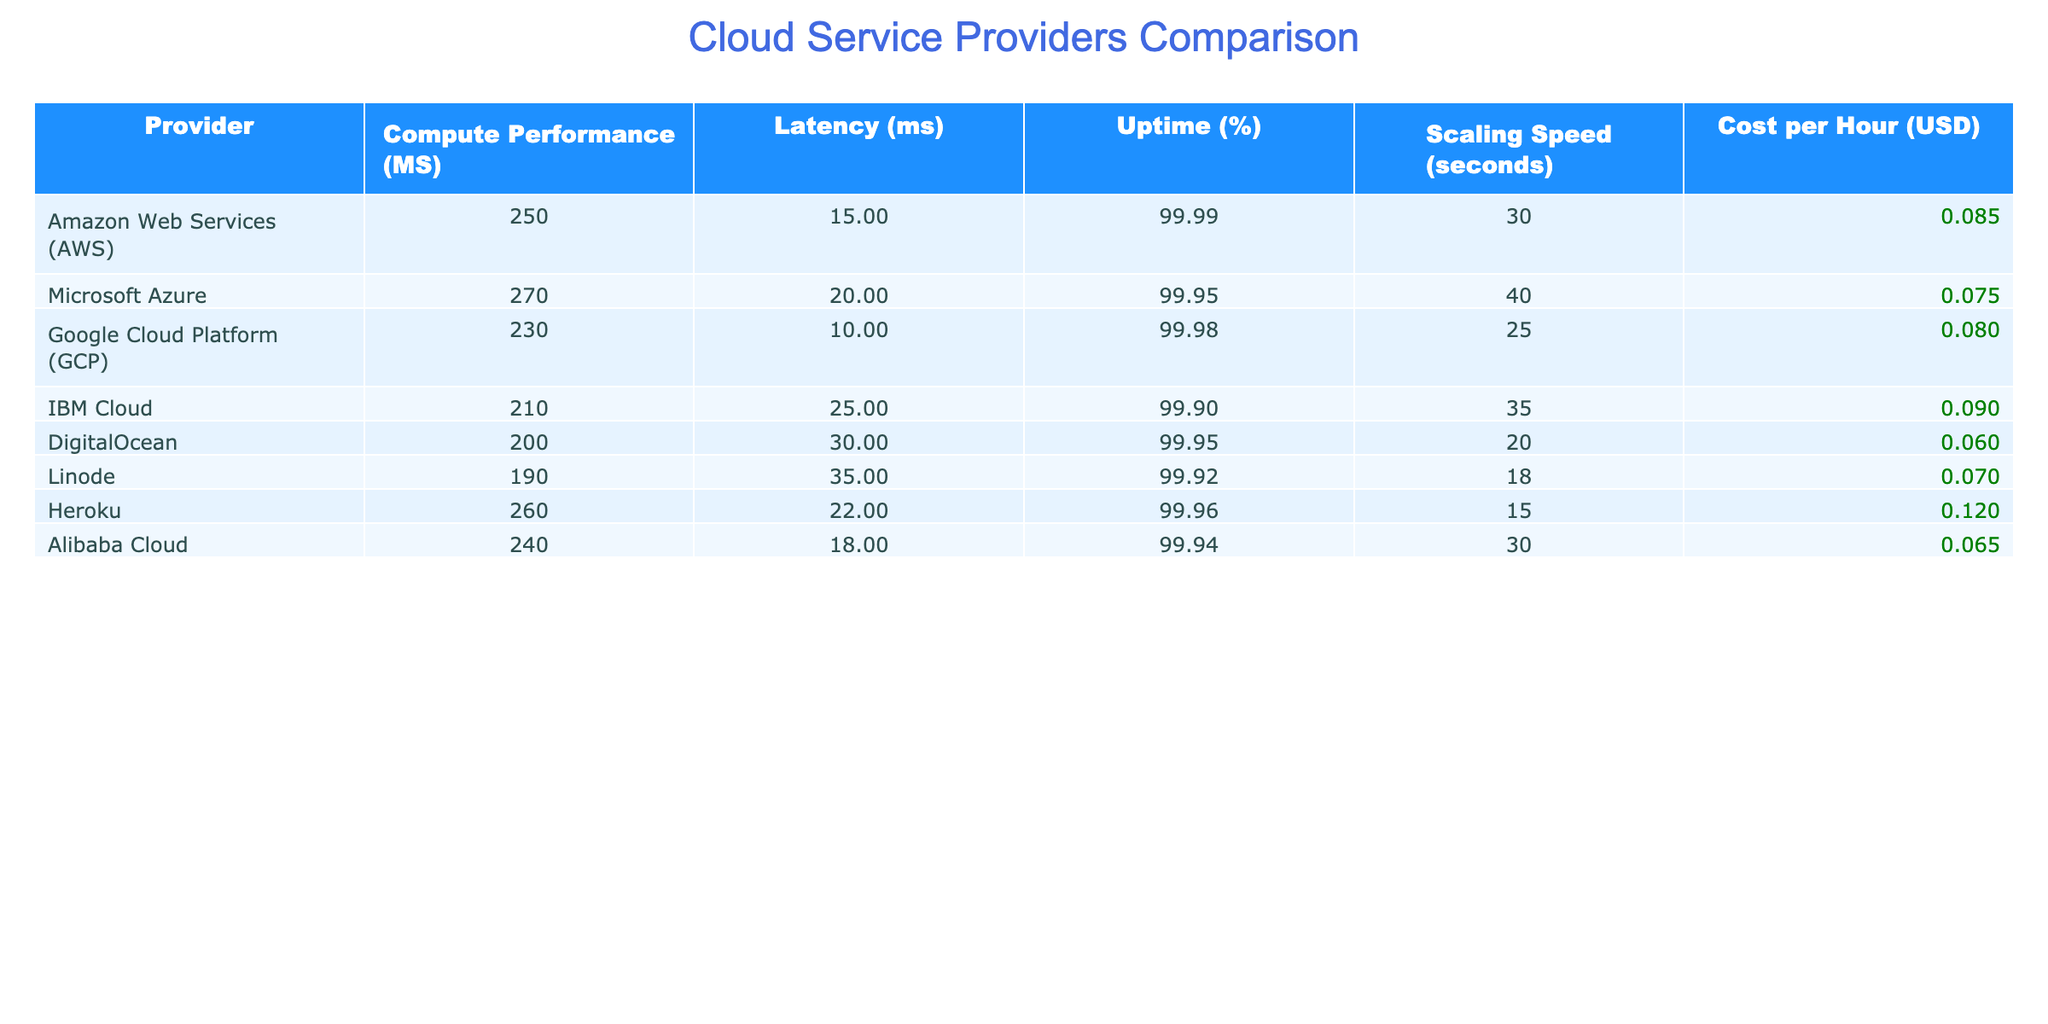What is the compute performance (MS) of Microsoft Azure? The table shows the compute performance of Microsoft Azure listed under the "Compute Performance (MS)" column, which indicates a value of 270.
Answer: 270 Which provider has the lowest latency? From the "Latency (ms)" column, we see that Google Cloud Platform has the lowest latency value, which is 10 ms.
Answer: 10 ms Is the uptime for DigitalOcean greater than 99%? The "Uptime (%)" column displays a value of 99.95 for DigitalOcean, which is indeed greater than 99%.
Answer: Yes What is the average cost per hour for all providers? To compute the average cost per hour, we add all the "Cost per Hour (USD)" values: 0.085 + 0.075 + 0.080 + 0.090 + 0.060 + 0.070 + 0.120 + 0.065 = 0.635. There are 8 providers, so the average cost is 0.635 / 8 = 0.079375.
Answer: 0.079375 Which provider has the highest uptime and what is that value? Looking at the "Uptime (%)" column, AWS has the highest uptime value of 99.99%, as seen in the table.
Answer: 99.99% How long does it take for Linode to scale? The scaling speed for Linode is listed under the "Scaling Speed (seconds)" as 18 seconds.
Answer: 18 seconds Is Heroku’s cost per hour expensive compared to DigitalOcean’s? By comparing the "Cost per Hour (USD)" values, Heroku's cost is 0.120 and DigitalOcean's is 0.060. Since 0.120 is more than 0.060, Heroku's cost per hour is more expensive.
Answer: Yes What’s the difference in network latency between IBM Cloud and Google Cloud Platform? The "Latency (ms)" for IBM Cloud is 25 ms and for Google Cloud Platform is 10 ms. To find the difference, we subtract: 25 - 10 = 15 ms.
Answer: 15 ms Which cloud service provides the fastest scaling speed? From the "Scaling Speed (seconds)" column, we can see that Heroku has the fastest scaling speed at 15 seconds.
Answer: 15 seconds 